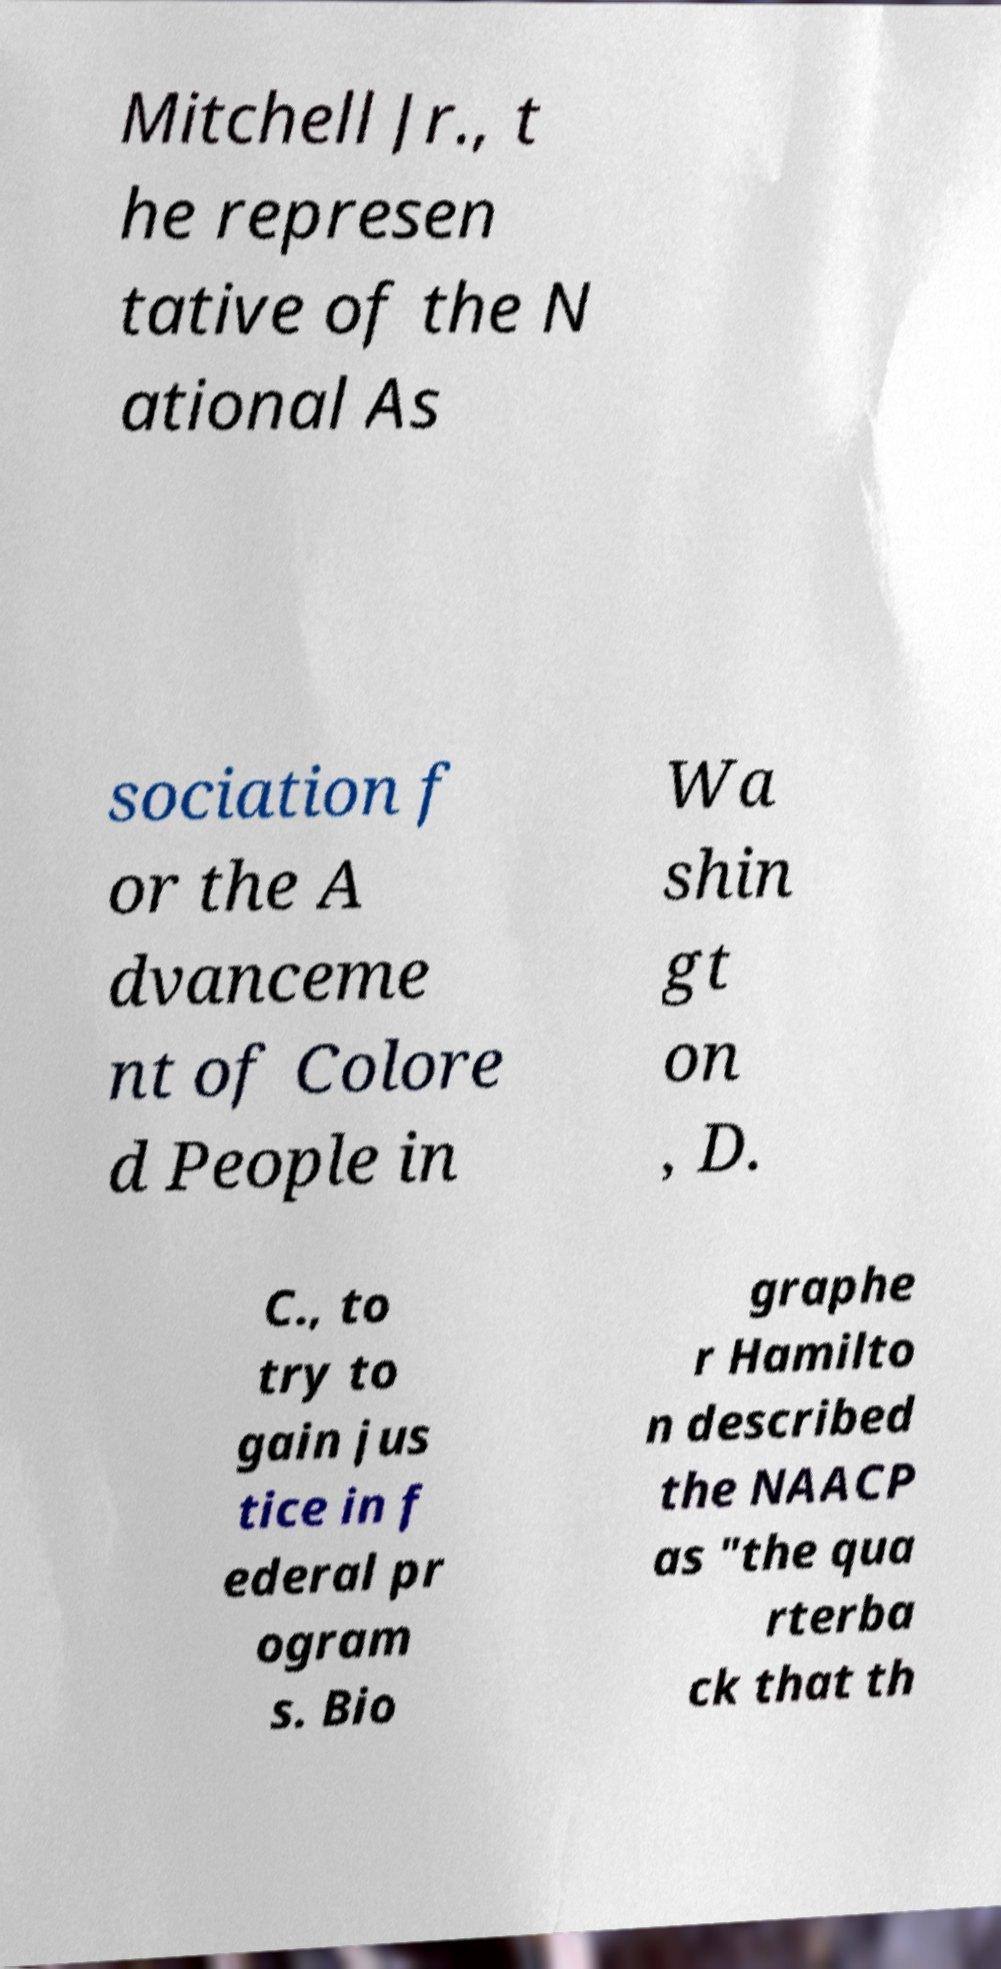Can you accurately transcribe the text from the provided image for me? Mitchell Jr., t he represen tative of the N ational As sociation f or the A dvanceme nt of Colore d People in Wa shin gt on , D. C., to try to gain jus tice in f ederal pr ogram s. Bio graphe r Hamilto n described the NAACP as "the qua rterba ck that th 